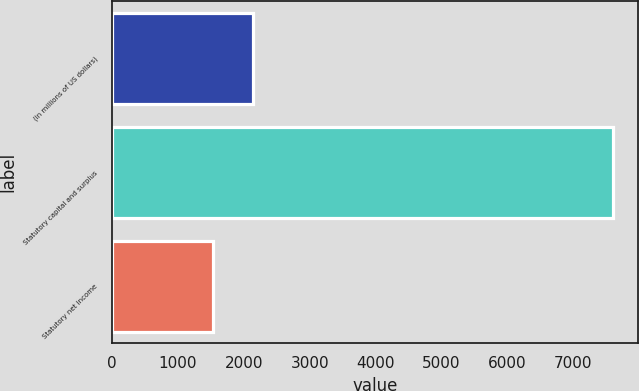Convert chart. <chart><loc_0><loc_0><loc_500><loc_500><bar_chart><fcel>(in millions of US dollars)<fcel>Statutory capital and surplus<fcel>Statutory net income<nl><fcel>2134.8<fcel>7605<fcel>1527<nl></chart> 